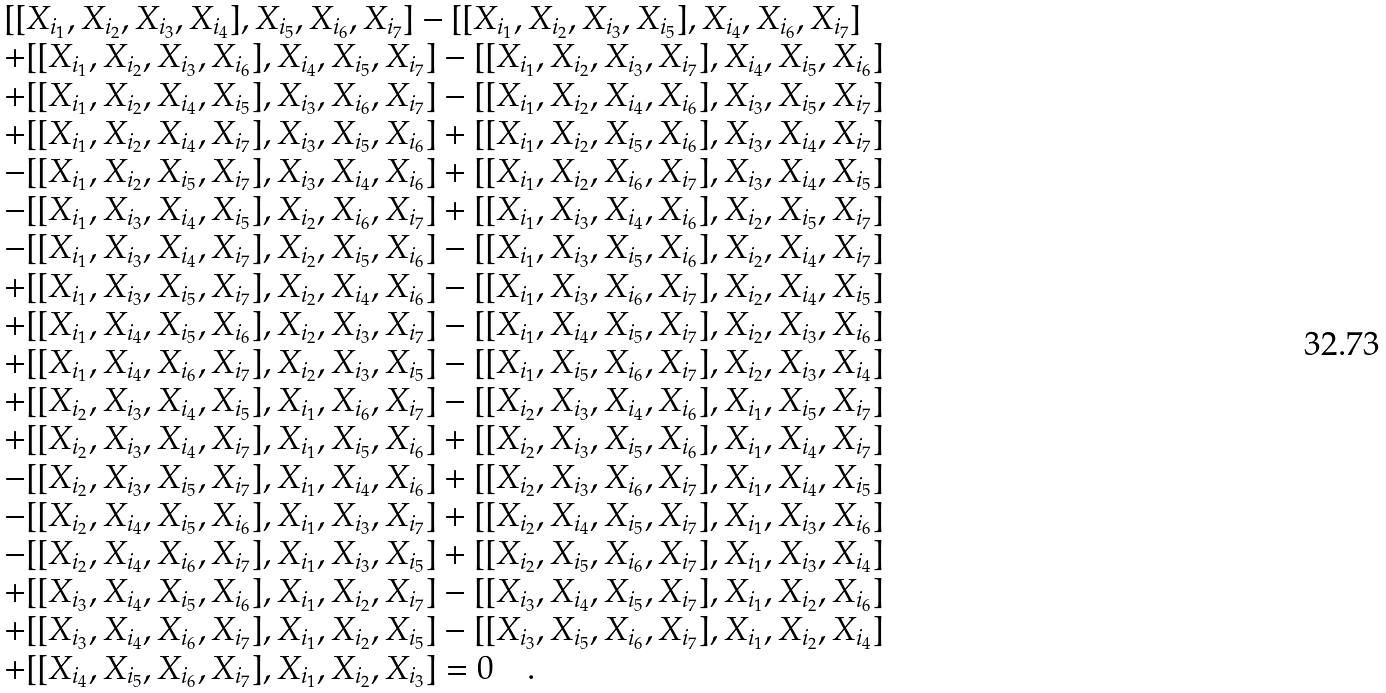<formula> <loc_0><loc_0><loc_500><loc_500>\begin{array} { l } [ [ X _ { i _ { 1 } } , X _ { i _ { 2 } } , X _ { i _ { 3 } } , X _ { i _ { 4 } } ] , X _ { i _ { 5 } } , X _ { i _ { 6 } } , X _ { i _ { 7 } } ] - [ [ X _ { i _ { 1 } } , X _ { i _ { 2 } } , X _ { i _ { 3 } } , X _ { i _ { 5 } } ] , X _ { i _ { 4 } } , X _ { i _ { 6 } } , X _ { i _ { 7 } } ] \\ + [ [ X _ { i _ { 1 } } , X _ { i _ { 2 } } , X _ { i _ { 3 } } , X _ { i _ { 6 } } ] , X _ { i _ { 4 } } , X _ { i _ { 5 } } , X _ { i _ { 7 } } ] - [ [ X _ { i _ { 1 } } , X _ { i _ { 2 } } , X _ { i _ { 3 } } , X _ { i _ { 7 } } ] , X _ { i _ { 4 } } , X _ { i _ { 5 } } , X _ { i _ { 6 } } ] \\ + [ [ X _ { i _ { 1 } } , X _ { i _ { 2 } } , X _ { i _ { 4 } } , X _ { i _ { 5 } } ] , X _ { i _ { 3 } } , X _ { i _ { 6 } } , X _ { i _ { 7 } } ] - [ [ X _ { i _ { 1 } } , X _ { i _ { 2 } } , X _ { i _ { 4 } } , X _ { i _ { 6 } } ] , X _ { i _ { 3 } } , X _ { i _ { 5 } } , X _ { i _ { 7 } } ] \\ + [ [ X _ { i _ { 1 } } , X _ { i _ { 2 } } , X _ { i _ { 4 } } , X _ { i _ { 7 } } ] , X _ { i _ { 3 } } , X _ { i _ { 5 } } , X _ { i _ { 6 } } ] + [ [ X _ { i _ { 1 } } , X _ { i _ { 2 } } , X _ { i _ { 5 } } , X _ { i _ { 6 } } ] , X _ { i _ { 3 } } , X _ { i _ { 4 } } , X _ { i _ { 7 } } ] \\ - [ [ X _ { i _ { 1 } } , X _ { i _ { 2 } } , X _ { i _ { 5 } } , X _ { i _ { 7 } } ] , X _ { i _ { 3 } } , X _ { i _ { 4 } } , X _ { i _ { 6 } } ] + [ [ X _ { i _ { 1 } } , X _ { i _ { 2 } } , X _ { i _ { 6 } } , X _ { i _ { 7 } } ] , X _ { i _ { 3 } } , X _ { i _ { 4 } } , X _ { i _ { 5 } } ] \\ - [ [ X _ { i _ { 1 } } , X _ { i _ { 3 } } , X _ { i _ { 4 } } , X _ { i _ { 5 } } ] , X _ { i _ { 2 } } , X _ { i _ { 6 } } , X _ { i _ { 7 } } ] + [ [ X _ { i _ { 1 } } , X _ { i _ { 3 } } , X _ { i _ { 4 } } , X _ { i _ { 6 } } ] , X _ { i _ { 2 } } , X _ { i _ { 5 } } , X _ { i _ { 7 } } ] \\ - [ [ X _ { i _ { 1 } } , X _ { i _ { 3 } } , X _ { i _ { 4 } } , X _ { i _ { 7 } } ] , X _ { i _ { 2 } } , X _ { i _ { 5 } } , X _ { i _ { 6 } } ] - [ [ X _ { i _ { 1 } } , X _ { i _ { 3 } } , X _ { i _ { 5 } } , X _ { i _ { 6 } } ] , X _ { i _ { 2 } } , X _ { i _ { 4 } } , X _ { i _ { 7 } } ] \\ + [ [ X _ { i _ { 1 } } , X _ { i _ { 3 } } , X _ { i _ { 5 } } , X _ { i _ { 7 } } ] , X _ { i _ { 2 } } , X _ { i _ { 4 } } , X _ { i _ { 6 } } ] - [ [ X _ { i _ { 1 } } , X _ { i _ { 3 } } , X _ { i _ { 6 } } , X _ { i _ { 7 } } ] , X _ { i _ { 2 } } , X _ { i _ { 4 } } , X _ { i _ { 5 } } ] \\ + [ [ X _ { i _ { 1 } } , X _ { i _ { 4 } } , X _ { i _ { 5 } } , X _ { i _ { 6 } } ] , X _ { i _ { 2 } } , X _ { i _ { 3 } } , X _ { i _ { 7 } } ] - [ [ X _ { i _ { 1 } } , X _ { i _ { 4 } } , X _ { i _ { 5 } } , X _ { i _ { 7 } } ] , X _ { i _ { 2 } } , X _ { i _ { 3 } } , X _ { i _ { 6 } } ] \\ + [ [ X _ { i _ { 1 } } , X _ { i _ { 4 } } , X _ { i _ { 6 } } , X _ { i _ { 7 } } ] , X _ { i _ { 2 } } , X _ { i _ { 3 } } , X _ { i _ { 5 } } ] - [ [ X _ { i _ { 1 } } , X _ { i _ { 5 } } , X _ { i _ { 6 } } , X _ { i _ { 7 } } ] , X _ { i _ { 2 } } , X _ { i _ { 3 } } , X _ { i _ { 4 } } ] \\ + [ [ X _ { i _ { 2 } } , X _ { i _ { 3 } } , X _ { i _ { 4 } } , X _ { i _ { 5 } } ] , X _ { i _ { 1 } } , X _ { i _ { 6 } } , X _ { i _ { 7 } } ] - [ [ X _ { i _ { 2 } } , X _ { i _ { 3 } } , X _ { i _ { 4 } } , X _ { i _ { 6 } } ] , X _ { i _ { 1 } } , X _ { i _ { 5 } } , X _ { i _ { 7 } } ] \\ + [ [ X _ { i _ { 2 } } , X _ { i _ { 3 } } , X _ { i _ { 4 } } , X _ { i _ { 7 } } ] , X _ { i _ { 1 } } , X _ { i _ { 5 } } , X _ { i _ { 6 } } ] + [ [ X _ { i _ { 2 } } , X _ { i _ { 3 } } , X _ { i _ { 5 } } , X _ { i _ { 6 } } ] , X _ { i _ { 1 } } , X _ { i _ { 4 } } , X _ { i _ { 7 } } ] \\ - [ [ X _ { i _ { 2 } } , X _ { i _ { 3 } } , X _ { i _ { 5 } } , X _ { i _ { 7 } } ] , X _ { i _ { 1 } } , X _ { i _ { 4 } } , X _ { i _ { 6 } } ] + [ [ X _ { i _ { 2 } } , X _ { i _ { 3 } } , X _ { i _ { 6 } } , X _ { i _ { 7 } } ] , X _ { i _ { 1 } } , X _ { i _ { 4 } } , X _ { i _ { 5 } } ] \\ - [ [ X _ { i _ { 2 } } , X _ { i _ { 4 } } , X _ { i _ { 5 } } , X _ { i _ { 6 } } ] , X _ { i _ { 1 } } , X _ { i _ { 3 } } , X _ { i _ { 7 } } ] + [ [ X _ { i _ { 2 } } , X _ { i _ { 4 } } , X _ { i _ { 5 } } , X _ { i _ { 7 } } ] , X _ { i _ { 1 } } , X _ { i _ { 3 } } , X _ { i _ { 6 } } ] \\ - [ [ X _ { i _ { 2 } } , X _ { i _ { 4 } } , X _ { i _ { 6 } } , X _ { i _ { 7 } } ] , X _ { i _ { 1 } } , X _ { i _ { 3 } } , X _ { i _ { 5 } } ] + [ [ X _ { i _ { 2 } } , X _ { i _ { 5 } } , X _ { i _ { 6 } } , X _ { i _ { 7 } } ] , X _ { i _ { 1 } } , X _ { i _ { 3 } } , X _ { i _ { 4 } } ] \\ + [ [ X _ { i _ { 3 } } , X _ { i _ { 4 } } , X _ { i _ { 5 } } , X _ { i _ { 6 } } ] , X _ { i _ { 1 } } , X _ { i _ { 2 } } , X _ { i _ { 7 } } ] - [ [ X _ { i _ { 3 } } , X _ { i _ { 4 } } , X _ { i _ { 5 } } , X _ { i _ { 7 } } ] , X _ { i _ { 1 } } , X _ { i _ { 2 } } , X _ { i _ { 6 } } ] \\ + [ [ X _ { i _ { 3 } } , X _ { i _ { 4 } } , X _ { i _ { 6 } } , X _ { i _ { 7 } } ] , X _ { i _ { 1 } } , X _ { i _ { 2 } } , X _ { i _ { 5 } } ] - [ [ X _ { i _ { 3 } } , X _ { i _ { 5 } } , X _ { i _ { 6 } } , X _ { i _ { 7 } } ] , X _ { i _ { 1 } } , X _ { i _ { 2 } } , X _ { i _ { 4 } } ] \\ + [ [ X _ { i _ { 4 } } , X _ { i _ { 5 } } , X _ { i _ { 6 } } , X _ { i _ { 7 } } ] , X _ { i _ { 1 } } , X _ { i _ { 2 } } , X _ { i _ { 3 } } ] = 0 \quad . \end{array}</formula> 